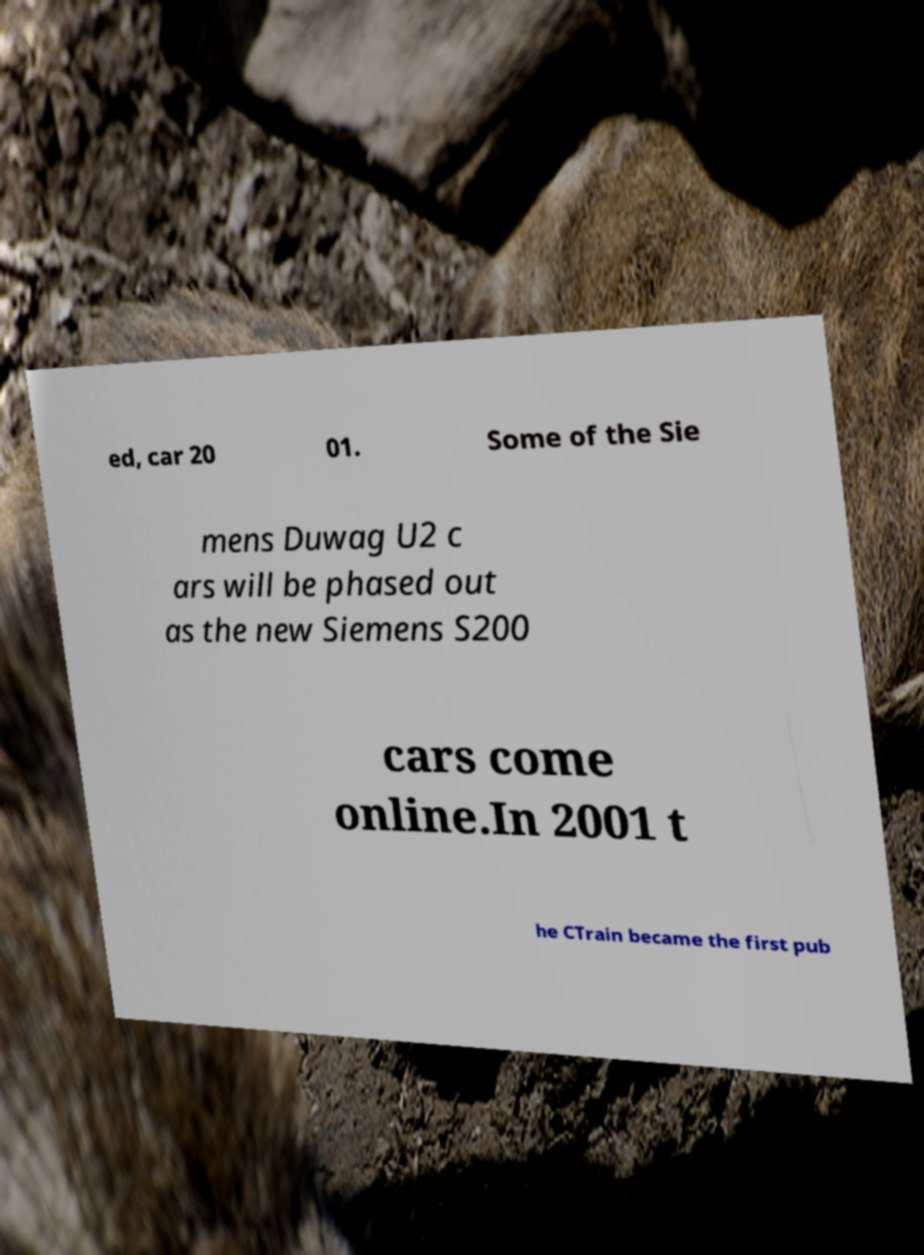Could you extract and type out the text from this image? ed, car 20 01. Some of the Sie mens Duwag U2 c ars will be phased out as the new Siemens S200 cars come online.In 2001 t he CTrain became the first pub 